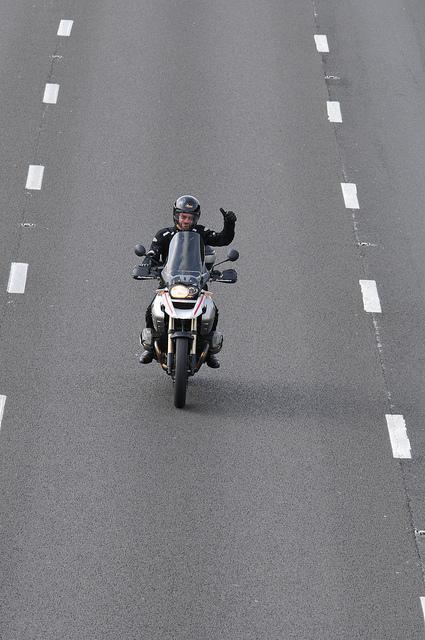How many bikes are on the road?
Give a very brief answer. 1. How many people can you see?
Give a very brief answer. 1. How many people have remotes in their hands?
Give a very brief answer. 0. 